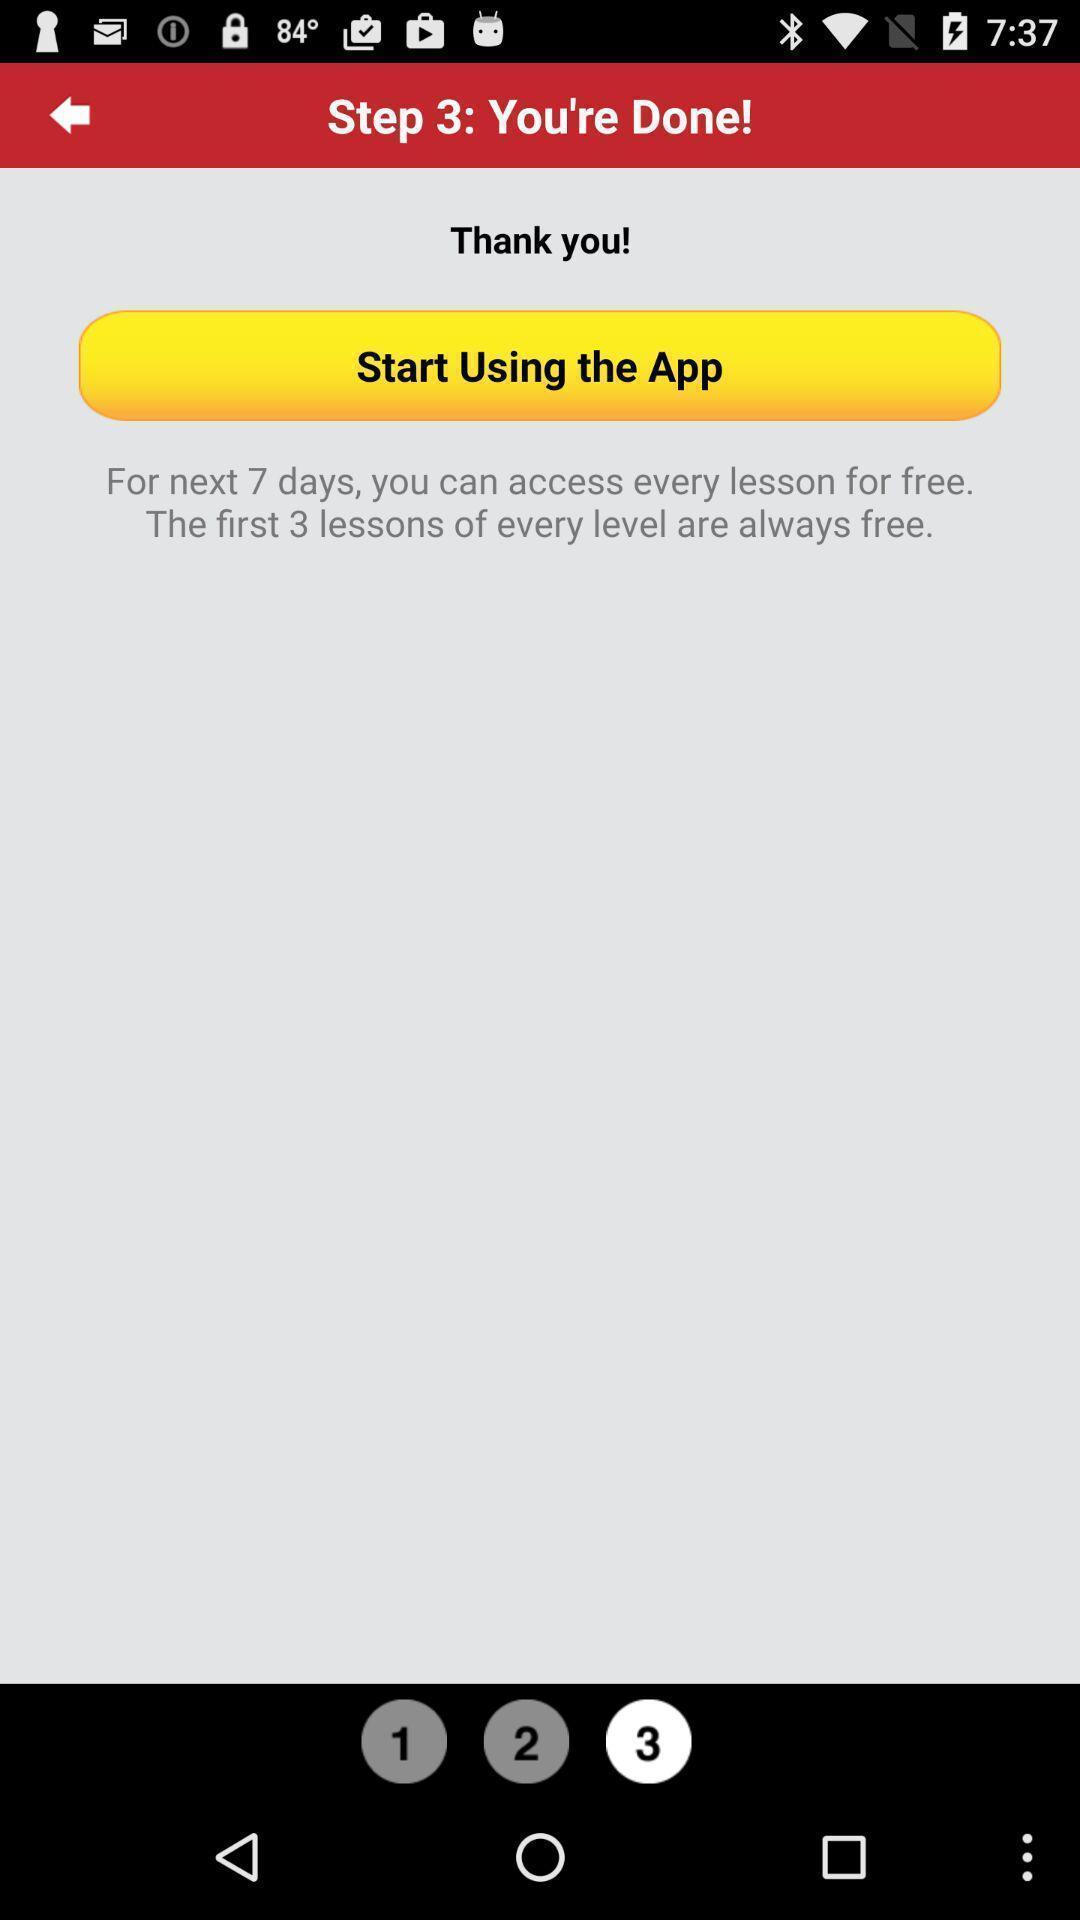Explain what's happening in this screen capture. Page showing information about starting an app. 